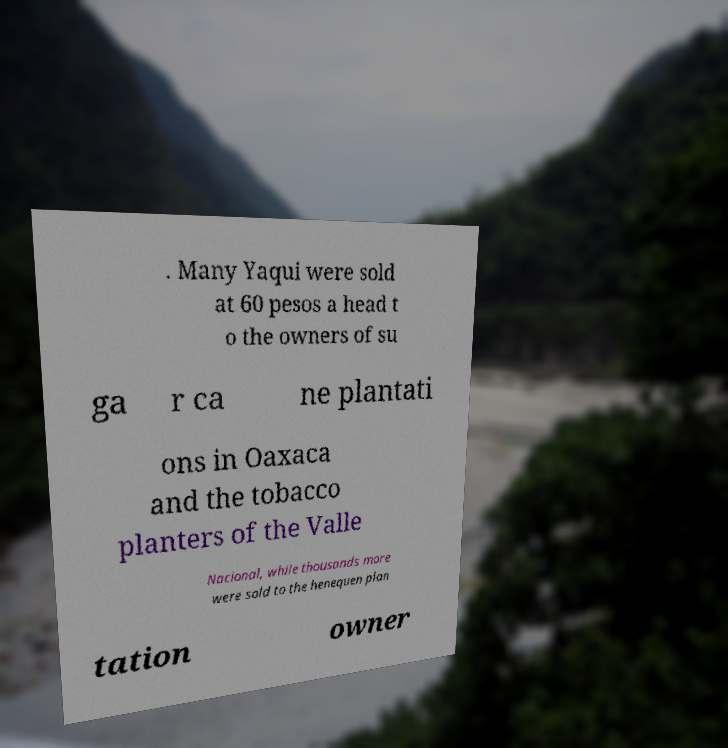Could you assist in decoding the text presented in this image and type it out clearly? . Many Yaqui were sold at 60 pesos a head t o the owners of su ga r ca ne plantati ons in Oaxaca and the tobacco planters of the Valle Nacional, while thousands more were sold to the henequen plan tation owner 